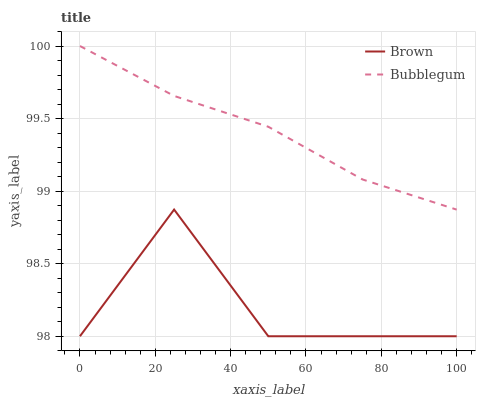Does Brown have the minimum area under the curve?
Answer yes or no. Yes. Does Bubblegum have the maximum area under the curve?
Answer yes or no. Yes. Does Bubblegum have the minimum area under the curve?
Answer yes or no. No. Is Bubblegum the smoothest?
Answer yes or no. Yes. Is Brown the roughest?
Answer yes or no. Yes. Is Bubblegum the roughest?
Answer yes or no. No. Does Brown have the lowest value?
Answer yes or no. Yes. Does Bubblegum have the lowest value?
Answer yes or no. No. Does Bubblegum have the highest value?
Answer yes or no. Yes. Is Brown less than Bubblegum?
Answer yes or no. Yes. Is Bubblegum greater than Brown?
Answer yes or no. Yes. Does Brown intersect Bubblegum?
Answer yes or no. No. 